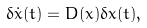<formula> <loc_0><loc_0><loc_500><loc_500>\delta \dot { x } ( t ) = D ( x ) \delta x ( t ) ,</formula> 